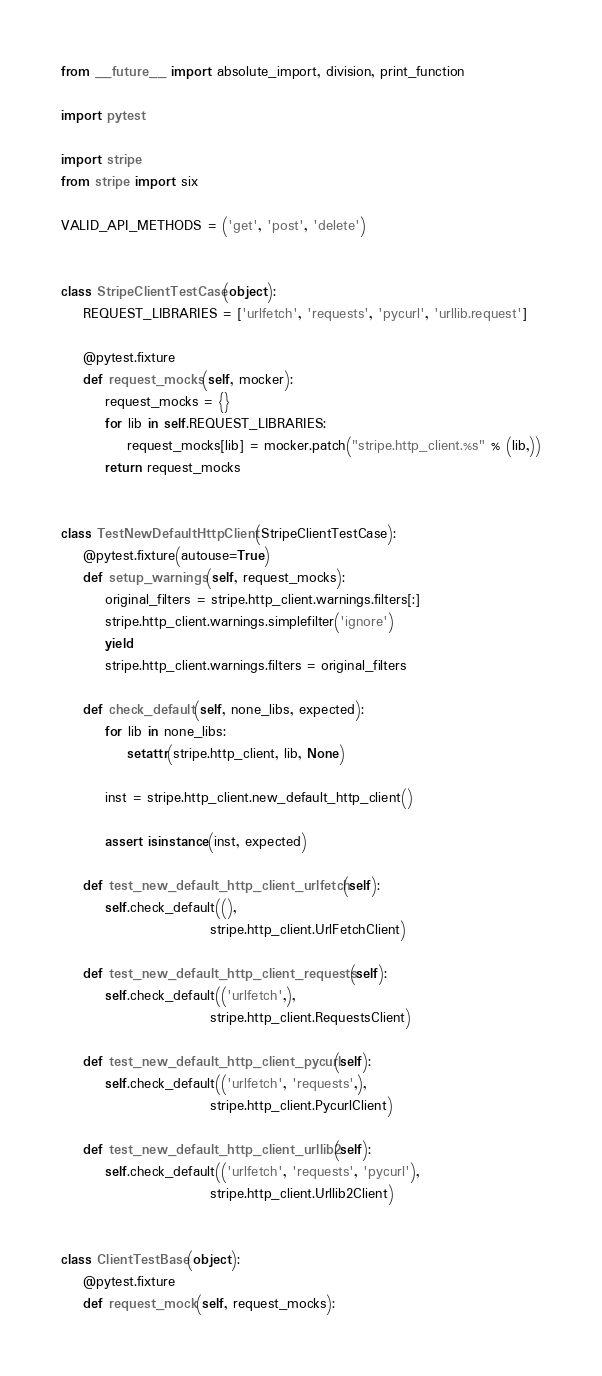<code> <loc_0><loc_0><loc_500><loc_500><_Python_>from __future__ import absolute_import, division, print_function

import pytest

import stripe
from stripe import six

VALID_API_METHODS = ('get', 'post', 'delete')


class StripeClientTestCase(object):
    REQUEST_LIBRARIES = ['urlfetch', 'requests', 'pycurl', 'urllib.request']

    @pytest.fixture
    def request_mocks(self, mocker):
        request_mocks = {}
        for lib in self.REQUEST_LIBRARIES:
            request_mocks[lib] = mocker.patch("stripe.http_client.%s" % (lib,))
        return request_mocks


class TestNewDefaultHttpClient(StripeClientTestCase):
    @pytest.fixture(autouse=True)
    def setup_warnings(self, request_mocks):
        original_filters = stripe.http_client.warnings.filters[:]
        stripe.http_client.warnings.simplefilter('ignore')
        yield
        stripe.http_client.warnings.filters = original_filters

    def check_default(self, none_libs, expected):
        for lib in none_libs:
            setattr(stripe.http_client, lib, None)

        inst = stripe.http_client.new_default_http_client()

        assert isinstance(inst, expected)

    def test_new_default_http_client_urlfetch(self):
        self.check_default((),
                           stripe.http_client.UrlFetchClient)

    def test_new_default_http_client_requests(self):
        self.check_default(('urlfetch',),
                           stripe.http_client.RequestsClient)

    def test_new_default_http_client_pycurl(self):
        self.check_default(('urlfetch', 'requests',),
                           stripe.http_client.PycurlClient)

    def test_new_default_http_client_urllib2(self):
        self.check_default(('urlfetch', 'requests', 'pycurl'),
                           stripe.http_client.Urllib2Client)


class ClientTestBase(object):
    @pytest.fixture
    def request_mock(self, request_mocks):</code> 